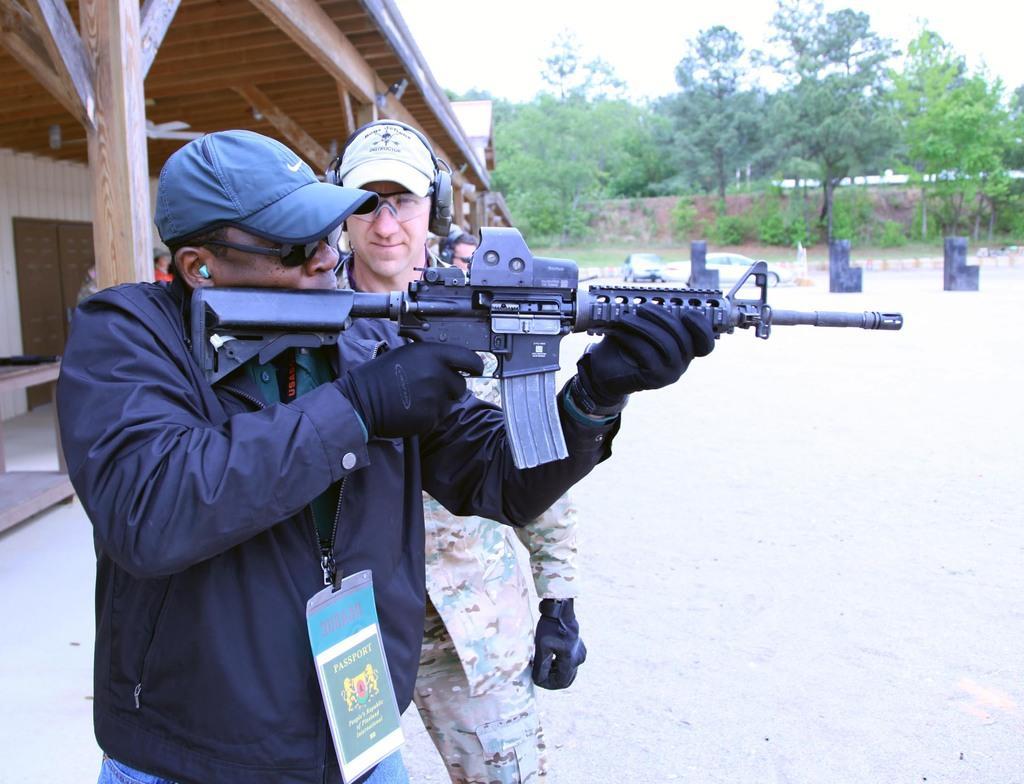Could you give a brief overview of what you see in this image? In the center of the image there are two persons standing. In the background of the image there are trees. To the left side of the image there is house. 